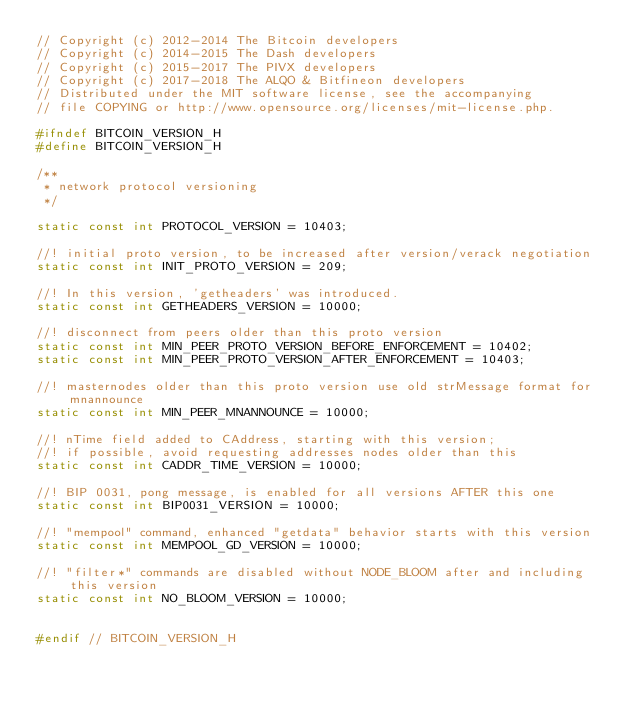<code> <loc_0><loc_0><loc_500><loc_500><_C_>// Copyright (c) 2012-2014 The Bitcoin developers
// Copyright (c) 2014-2015 The Dash developers
// Copyright (c) 2015-2017 The PIVX developers
// Copyright (c) 2017-2018 The ALQO & Bitfineon developers
// Distributed under the MIT software license, see the accompanying
// file COPYING or http://www.opensource.org/licenses/mit-license.php.

#ifndef BITCOIN_VERSION_H
#define BITCOIN_VERSION_H

/**
 * network protocol versioning
 */

static const int PROTOCOL_VERSION = 10403;

//! initial proto version, to be increased after version/verack negotiation
static const int INIT_PROTO_VERSION = 209;

//! In this version, 'getheaders' was introduced.
static const int GETHEADERS_VERSION = 10000;

//! disconnect from peers older than this proto version
static const int MIN_PEER_PROTO_VERSION_BEFORE_ENFORCEMENT = 10402;
static const int MIN_PEER_PROTO_VERSION_AFTER_ENFORCEMENT = 10403;

//! masternodes older than this proto version use old strMessage format for mnannounce
static const int MIN_PEER_MNANNOUNCE = 10000;

//! nTime field added to CAddress, starting with this version;
//! if possible, avoid requesting addresses nodes older than this
static const int CADDR_TIME_VERSION = 10000;

//! BIP 0031, pong message, is enabled for all versions AFTER this one
static const int BIP0031_VERSION = 10000;

//! "mempool" command, enhanced "getdata" behavior starts with this version
static const int MEMPOOL_GD_VERSION = 10000;

//! "filter*" commands are disabled without NODE_BLOOM after and including this version
static const int NO_BLOOM_VERSION = 10000;


#endif // BITCOIN_VERSION_H
</code> 